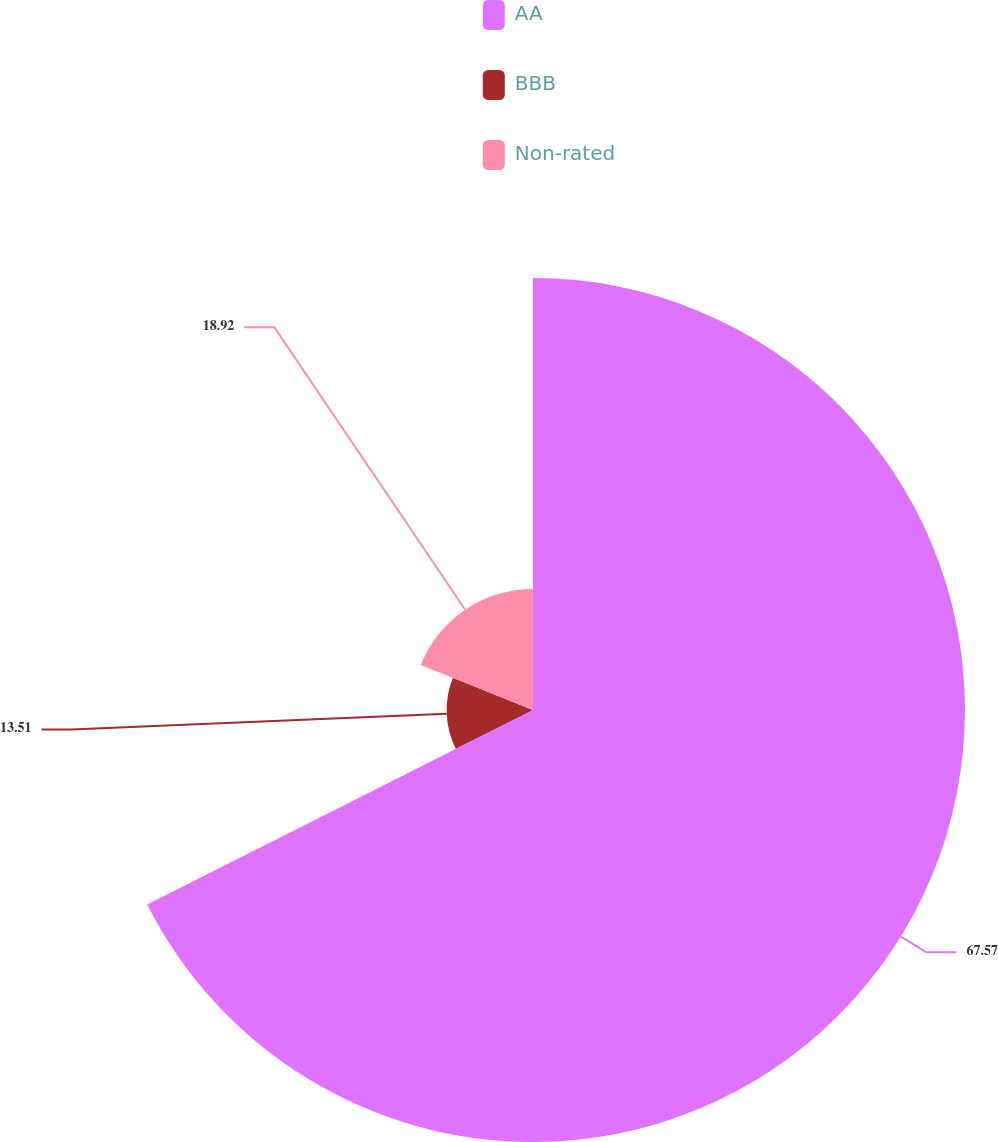Convert chart to OTSL. <chart><loc_0><loc_0><loc_500><loc_500><pie_chart><fcel>AA<fcel>BBB<fcel>Non-rated<nl><fcel>67.57%<fcel>13.51%<fcel>18.92%<nl></chart> 